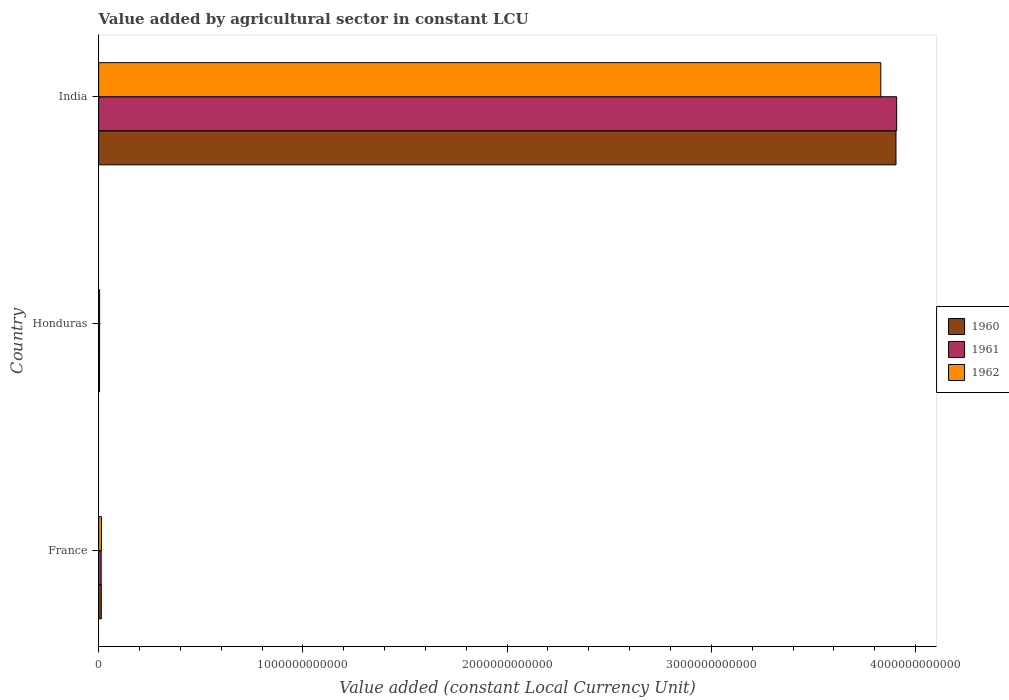How many different coloured bars are there?
Make the answer very short. 3. Are the number of bars per tick equal to the number of legend labels?
Your response must be concise. Yes. Are the number of bars on each tick of the Y-axis equal?
Your response must be concise. Yes. How many bars are there on the 3rd tick from the bottom?
Your response must be concise. 3. In how many cases, is the number of bars for a given country not equal to the number of legend labels?
Offer a terse response. 0. What is the value added by agricultural sector in 1961 in France?
Keep it short and to the point. 1.25e+1. Across all countries, what is the maximum value added by agricultural sector in 1961?
Your answer should be compact. 3.91e+12. Across all countries, what is the minimum value added by agricultural sector in 1960?
Your response must be concise. 4.44e+09. In which country was the value added by agricultural sector in 1962 minimum?
Offer a very short reply. Honduras. What is the total value added by agricultural sector in 1960 in the graph?
Make the answer very short. 3.92e+12. What is the difference between the value added by agricultural sector in 1960 in France and that in India?
Offer a very short reply. -3.89e+12. What is the difference between the value added by agricultural sector in 1961 in India and the value added by agricultural sector in 1962 in France?
Your answer should be very brief. 3.89e+12. What is the average value added by agricultural sector in 1960 per country?
Offer a terse response. 1.31e+12. What is the difference between the value added by agricultural sector in 1962 and value added by agricultural sector in 1960 in India?
Your answer should be very brief. -7.44e+1. What is the ratio of the value added by agricultural sector in 1961 in France to that in Honduras?
Give a very brief answer. 2.64. Is the value added by agricultural sector in 1960 in France less than that in Honduras?
Keep it short and to the point. No. Is the difference between the value added by agricultural sector in 1962 in France and Honduras greater than the difference between the value added by agricultural sector in 1960 in France and Honduras?
Provide a short and direct response. No. What is the difference between the highest and the second highest value added by agricultural sector in 1961?
Keep it short and to the point. 3.90e+12. What is the difference between the highest and the lowest value added by agricultural sector in 1961?
Provide a succinct answer. 3.90e+12. Is the sum of the value added by agricultural sector in 1960 in Honduras and India greater than the maximum value added by agricultural sector in 1962 across all countries?
Offer a very short reply. Yes. What does the 3rd bar from the top in Honduras represents?
Your answer should be compact. 1960. Is it the case that in every country, the sum of the value added by agricultural sector in 1961 and value added by agricultural sector in 1962 is greater than the value added by agricultural sector in 1960?
Make the answer very short. Yes. How many bars are there?
Make the answer very short. 9. Are all the bars in the graph horizontal?
Offer a terse response. Yes. What is the difference between two consecutive major ticks on the X-axis?
Offer a terse response. 1.00e+12. Are the values on the major ticks of X-axis written in scientific E-notation?
Your response must be concise. No. Does the graph contain grids?
Your answer should be compact. No. Where does the legend appear in the graph?
Offer a very short reply. Center right. How are the legend labels stacked?
Your answer should be compact. Vertical. What is the title of the graph?
Offer a very short reply. Value added by agricultural sector in constant LCU. What is the label or title of the X-axis?
Offer a very short reply. Value added (constant Local Currency Unit). What is the label or title of the Y-axis?
Your answer should be compact. Country. What is the Value added (constant Local Currency Unit) of 1960 in France?
Your answer should be compact. 1.32e+1. What is the Value added (constant Local Currency Unit) of 1961 in France?
Keep it short and to the point. 1.25e+1. What is the Value added (constant Local Currency Unit) in 1962 in France?
Provide a short and direct response. 1.36e+1. What is the Value added (constant Local Currency Unit) in 1960 in Honduras?
Your answer should be very brief. 4.44e+09. What is the Value added (constant Local Currency Unit) of 1961 in Honduras?
Offer a very short reply. 4.73e+09. What is the Value added (constant Local Currency Unit) in 1962 in Honduras?
Give a very brief answer. 4.96e+09. What is the Value added (constant Local Currency Unit) of 1960 in India?
Provide a succinct answer. 3.90e+12. What is the Value added (constant Local Currency Unit) in 1961 in India?
Your response must be concise. 3.91e+12. What is the Value added (constant Local Currency Unit) in 1962 in India?
Keep it short and to the point. 3.83e+12. Across all countries, what is the maximum Value added (constant Local Currency Unit) in 1960?
Provide a short and direct response. 3.90e+12. Across all countries, what is the maximum Value added (constant Local Currency Unit) of 1961?
Your answer should be very brief. 3.91e+12. Across all countries, what is the maximum Value added (constant Local Currency Unit) of 1962?
Provide a succinct answer. 3.83e+12. Across all countries, what is the minimum Value added (constant Local Currency Unit) of 1960?
Your answer should be very brief. 4.44e+09. Across all countries, what is the minimum Value added (constant Local Currency Unit) of 1961?
Provide a short and direct response. 4.73e+09. Across all countries, what is the minimum Value added (constant Local Currency Unit) of 1962?
Offer a terse response. 4.96e+09. What is the total Value added (constant Local Currency Unit) in 1960 in the graph?
Give a very brief answer. 3.92e+12. What is the total Value added (constant Local Currency Unit) of 1961 in the graph?
Offer a terse response. 3.92e+12. What is the total Value added (constant Local Currency Unit) in 1962 in the graph?
Your answer should be very brief. 3.85e+12. What is the difference between the Value added (constant Local Currency Unit) in 1960 in France and that in Honduras?
Your answer should be very brief. 8.72e+09. What is the difference between the Value added (constant Local Currency Unit) in 1961 in France and that in Honduras?
Offer a very short reply. 7.74e+09. What is the difference between the Value added (constant Local Currency Unit) in 1962 in France and that in Honduras?
Provide a succinct answer. 8.63e+09. What is the difference between the Value added (constant Local Currency Unit) in 1960 in France and that in India?
Keep it short and to the point. -3.89e+12. What is the difference between the Value added (constant Local Currency Unit) of 1961 in France and that in India?
Offer a terse response. -3.90e+12. What is the difference between the Value added (constant Local Currency Unit) of 1962 in France and that in India?
Your answer should be very brief. -3.82e+12. What is the difference between the Value added (constant Local Currency Unit) of 1960 in Honduras and that in India?
Offer a terse response. -3.90e+12. What is the difference between the Value added (constant Local Currency Unit) of 1961 in Honduras and that in India?
Ensure brevity in your answer.  -3.90e+12. What is the difference between the Value added (constant Local Currency Unit) in 1962 in Honduras and that in India?
Your answer should be compact. -3.82e+12. What is the difference between the Value added (constant Local Currency Unit) of 1960 in France and the Value added (constant Local Currency Unit) of 1961 in Honduras?
Provide a succinct answer. 8.43e+09. What is the difference between the Value added (constant Local Currency Unit) in 1960 in France and the Value added (constant Local Currency Unit) in 1962 in Honduras?
Make the answer very short. 8.20e+09. What is the difference between the Value added (constant Local Currency Unit) in 1961 in France and the Value added (constant Local Currency Unit) in 1962 in Honduras?
Ensure brevity in your answer.  7.52e+09. What is the difference between the Value added (constant Local Currency Unit) in 1960 in France and the Value added (constant Local Currency Unit) in 1961 in India?
Provide a succinct answer. -3.89e+12. What is the difference between the Value added (constant Local Currency Unit) in 1960 in France and the Value added (constant Local Currency Unit) in 1962 in India?
Provide a succinct answer. -3.82e+12. What is the difference between the Value added (constant Local Currency Unit) of 1961 in France and the Value added (constant Local Currency Unit) of 1962 in India?
Provide a short and direct response. -3.82e+12. What is the difference between the Value added (constant Local Currency Unit) in 1960 in Honduras and the Value added (constant Local Currency Unit) in 1961 in India?
Your answer should be compact. -3.90e+12. What is the difference between the Value added (constant Local Currency Unit) in 1960 in Honduras and the Value added (constant Local Currency Unit) in 1962 in India?
Make the answer very short. -3.83e+12. What is the difference between the Value added (constant Local Currency Unit) of 1961 in Honduras and the Value added (constant Local Currency Unit) of 1962 in India?
Offer a very short reply. -3.83e+12. What is the average Value added (constant Local Currency Unit) in 1960 per country?
Keep it short and to the point. 1.31e+12. What is the average Value added (constant Local Currency Unit) of 1961 per country?
Keep it short and to the point. 1.31e+12. What is the average Value added (constant Local Currency Unit) in 1962 per country?
Your answer should be very brief. 1.28e+12. What is the difference between the Value added (constant Local Currency Unit) in 1960 and Value added (constant Local Currency Unit) in 1961 in France?
Your answer should be very brief. 6.84e+08. What is the difference between the Value added (constant Local Currency Unit) in 1960 and Value added (constant Local Currency Unit) in 1962 in France?
Provide a short and direct response. -4.23e+08. What is the difference between the Value added (constant Local Currency Unit) of 1961 and Value added (constant Local Currency Unit) of 1962 in France?
Your answer should be compact. -1.11e+09. What is the difference between the Value added (constant Local Currency Unit) of 1960 and Value added (constant Local Currency Unit) of 1961 in Honduras?
Provide a short and direct response. -2.90e+08. What is the difference between the Value added (constant Local Currency Unit) in 1960 and Value added (constant Local Currency Unit) in 1962 in Honduras?
Your answer should be very brief. -5.15e+08. What is the difference between the Value added (constant Local Currency Unit) of 1961 and Value added (constant Local Currency Unit) of 1962 in Honduras?
Provide a succinct answer. -2.25e+08. What is the difference between the Value added (constant Local Currency Unit) in 1960 and Value added (constant Local Currency Unit) in 1961 in India?
Your answer should be compact. -3.29e+09. What is the difference between the Value added (constant Local Currency Unit) of 1960 and Value added (constant Local Currency Unit) of 1962 in India?
Offer a very short reply. 7.44e+1. What is the difference between the Value added (constant Local Currency Unit) of 1961 and Value added (constant Local Currency Unit) of 1962 in India?
Ensure brevity in your answer.  7.77e+1. What is the ratio of the Value added (constant Local Currency Unit) in 1960 in France to that in Honduras?
Your answer should be very brief. 2.96. What is the ratio of the Value added (constant Local Currency Unit) in 1961 in France to that in Honduras?
Keep it short and to the point. 2.64. What is the ratio of the Value added (constant Local Currency Unit) in 1962 in France to that in Honduras?
Offer a very short reply. 2.74. What is the ratio of the Value added (constant Local Currency Unit) of 1960 in France to that in India?
Give a very brief answer. 0. What is the ratio of the Value added (constant Local Currency Unit) of 1961 in France to that in India?
Your response must be concise. 0. What is the ratio of the Value added (constant Local Currency Unit) in 1962 in France to that in India?
Offer a very short reply. 0. What is the ratio of the Value added (constant Local Currency Unit) of 1960 in Honduras to that in India?
Keep it short and to the point. 0. What is the ratio of the Value added (constant Local Currency Unit) of 1961 in Honduras to that in India?
Your response must be concise. 0. What is the ratio of the Value added (constant Local Currency Unit) of 1962 in Honduras to that in India?
Your answer should be very brief. 0. What is the difference between the highest and the second highest Value added (constant Local Currency Unit) in 1960?
Provide a short and direct response. 3.89e+12. What is the difference between the highest and the second highest Value added (constant Local Currency Unit) of 1961?
Give a very brief answer. 3.90e+12. What is the difference between the highest and the second highest Value added (constant Local Currency Unit) of 1962?
Provide a succinct answer. 3.82e+12. What is the difference between the highest and the lowest Value added (constant Local Currency Unit) of 1960?
Provide a short and direct response. 3.90e+12. What is the difference between the highest and the lowest Value added (constant Local Currency Unit) in 1961?
Provide a succinct answer. 3.90e+12. What is the difference between the highest and the lowest Value added (constant Local Currency Unit) in 1962?
Provide a succinct answer. 3.82e+12. 